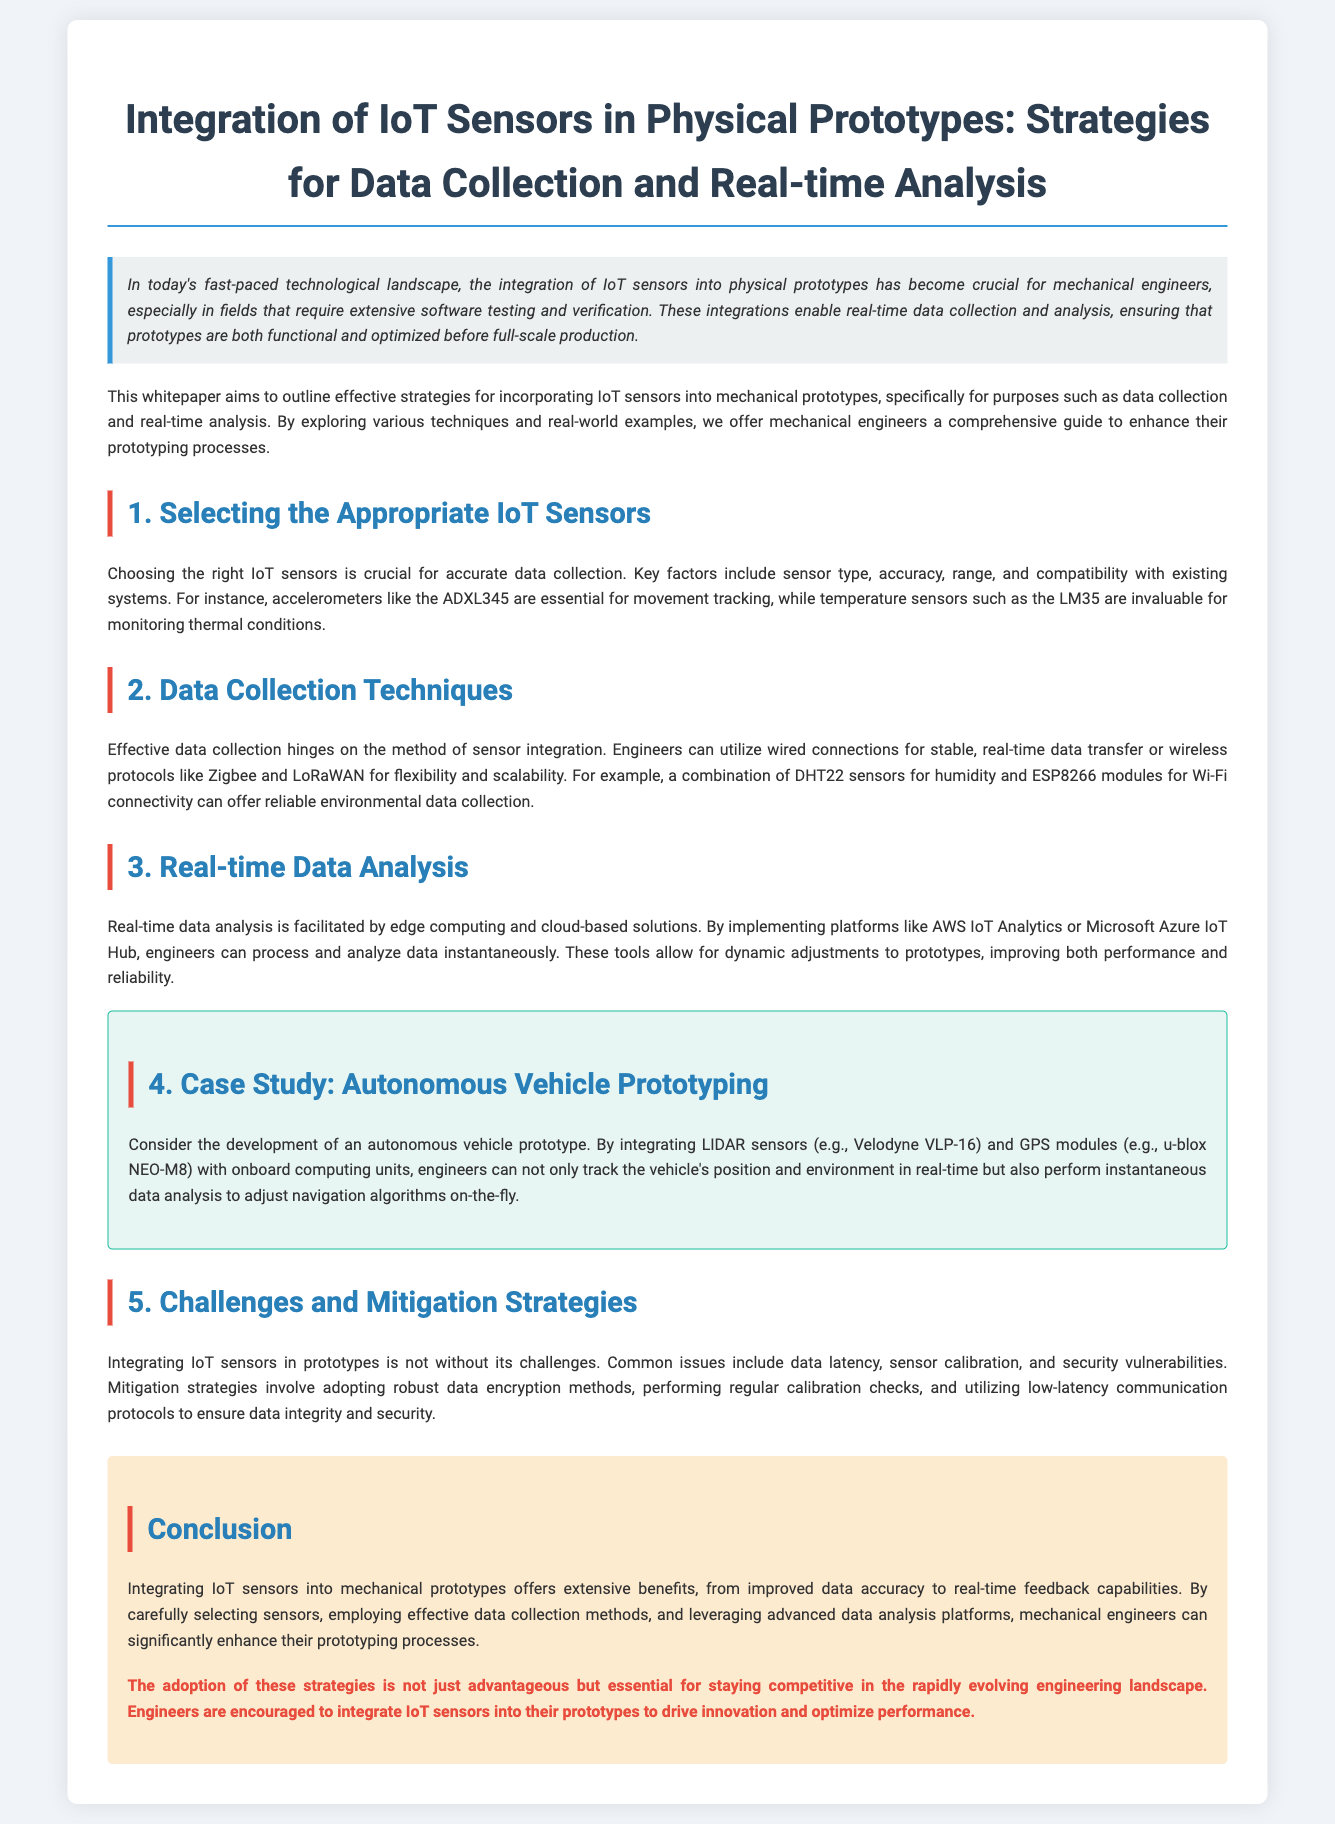what is the title of the whitepaper? The title is explicitly stated at the top of the document and summarizes the main focus of the paper.
Answer: Integration of IoT Sensors in Physical Prototypes: Strategies for Data Collection and Real-time Analysis which IoT sensor is mentioned for movement tracking? The document specifies an example of an accelerometer used for movement tracking.
Answer: ADXL345 what data protocol is suggested for flexibility in data transfer? This information is found in the section discussing data collection techniques and provides examples of wireless methods.
Answer: Zigbee what is a critical challenge mentioned in integrating IoT sensors? The document lists common issues faced during integration, emphasizing the need for solutions.
Answer: Data latency which platform is mentioned for real-time data analysis? The document refers to specific platforms that facilitate real-time data processing for engineers.
Answer: AWS IoT Analytics how does the case study improve vehicle navigation? The case study discusses a specific integration that allows real-time adjustments to navigation based on data.
Answer: Instantaneous data analysis what is the recommended method for ensuring data security? This is discussed in the challenges and mitigation strategies section, highlighting a key requirement for secure data handling.
Answer: Data encryption methods what type of sensors does the document suggest for monitoring thermal conditions? This information is included in the section on selecting appropriate sensors.
Answer: LM35 